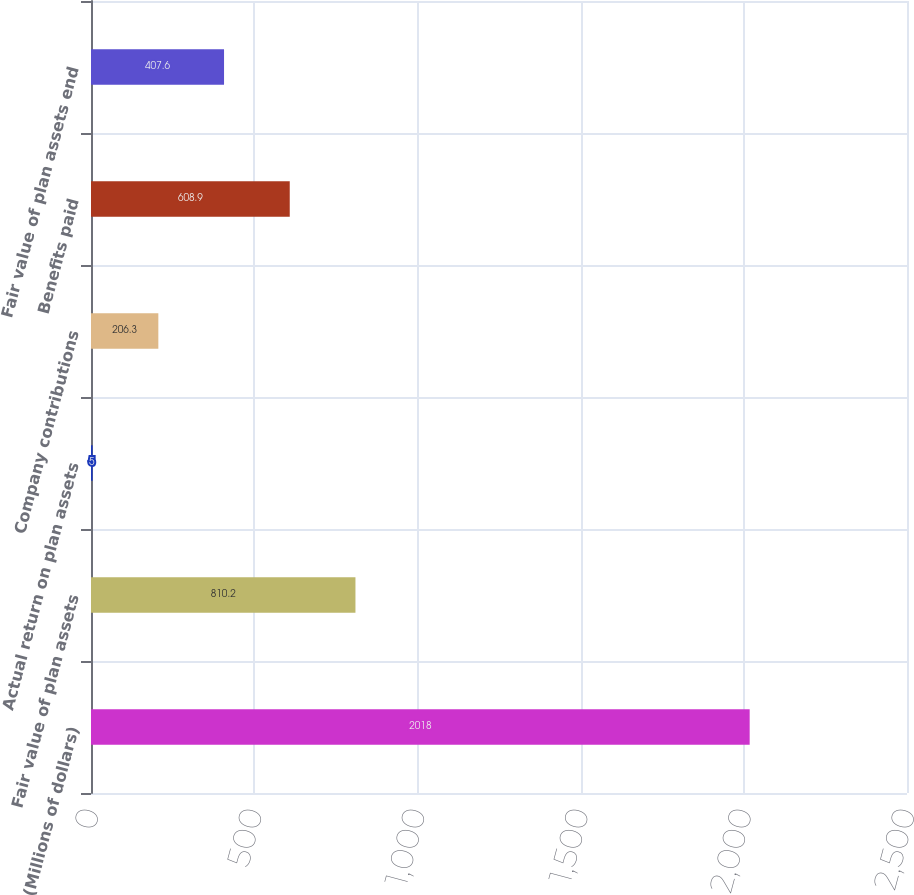Convert chart to OTSL. <chart><loc_0><loc_0><loc_500><loc_500><bar_chart><fcel>(Millions of dollars)<fcel>Fair value of plan assets<fcel>Actual return on plan assets<fcel>Company contributions<fcel>Benefits paid<fcel>Fair value of plan assets end<nl><fcel>2018<fcel>810.2<fcel>5<fcel>206.3<fcel>608.9<fcel>407.6<nl></chart> 